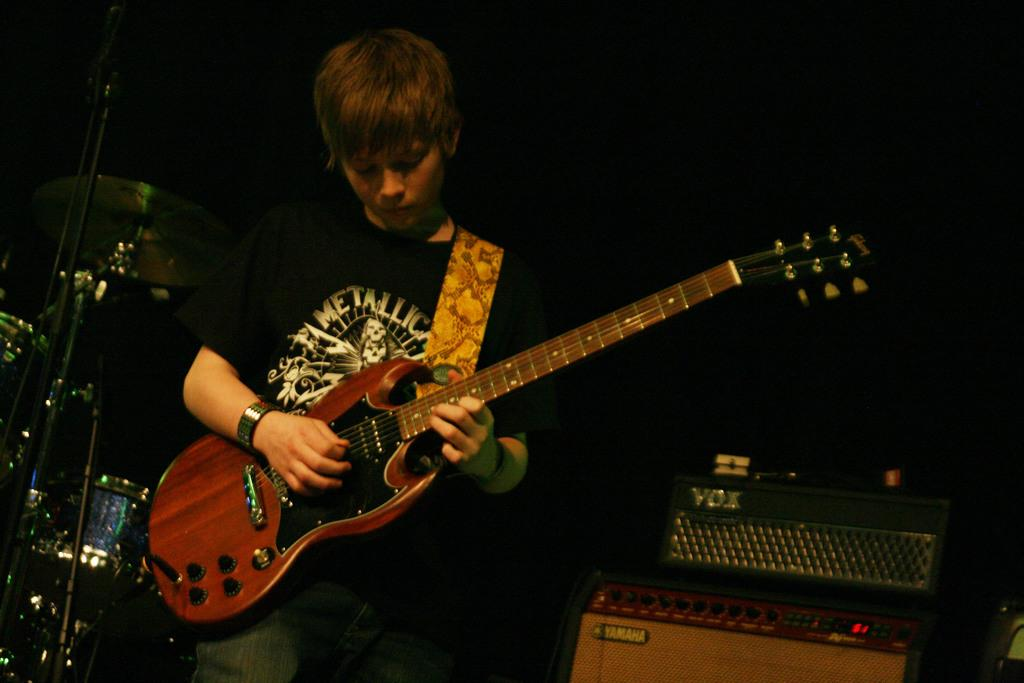What is the main feature of the image? There is a stage in the image. What can be seen on the stage? There are two musical instruments and drums on the stage. What is a person doing on the stage? A person is playing the guitar on the stage. What type of silk material is being used to cover the drums in the image? There is no silk material or any type of covering mentioned on the drums in the image. 